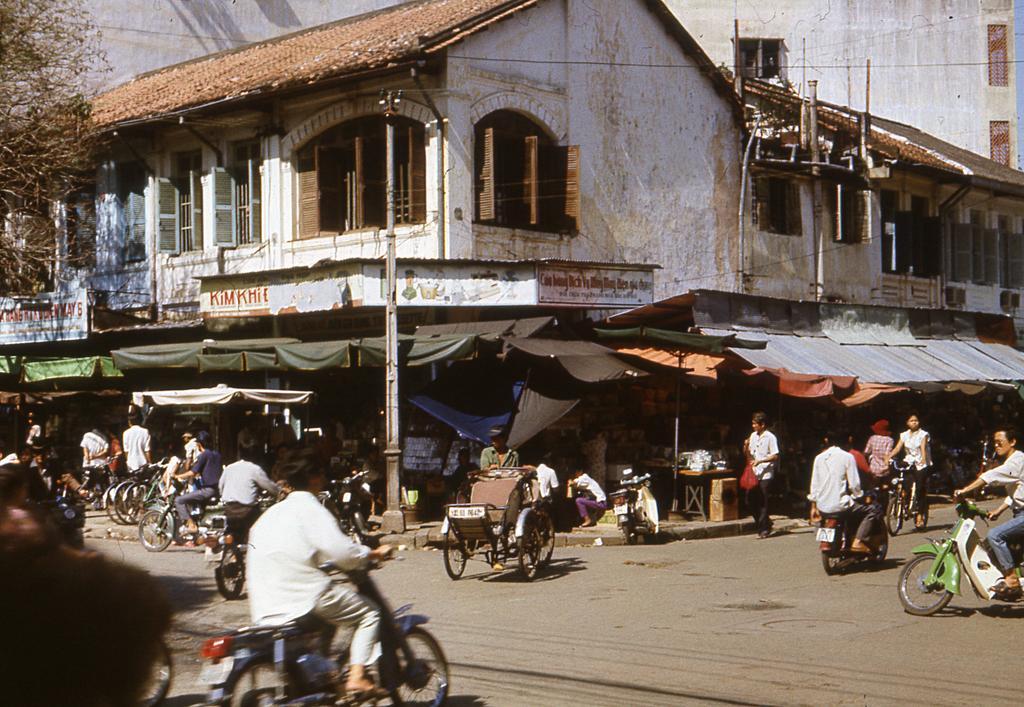How would you summarize this image in a sentence or two? In this image there are buildings and we can see people. At the bottom there are vehicles on the road. On the left there is a tree and we can see boards. There are tents and we can see wires. 